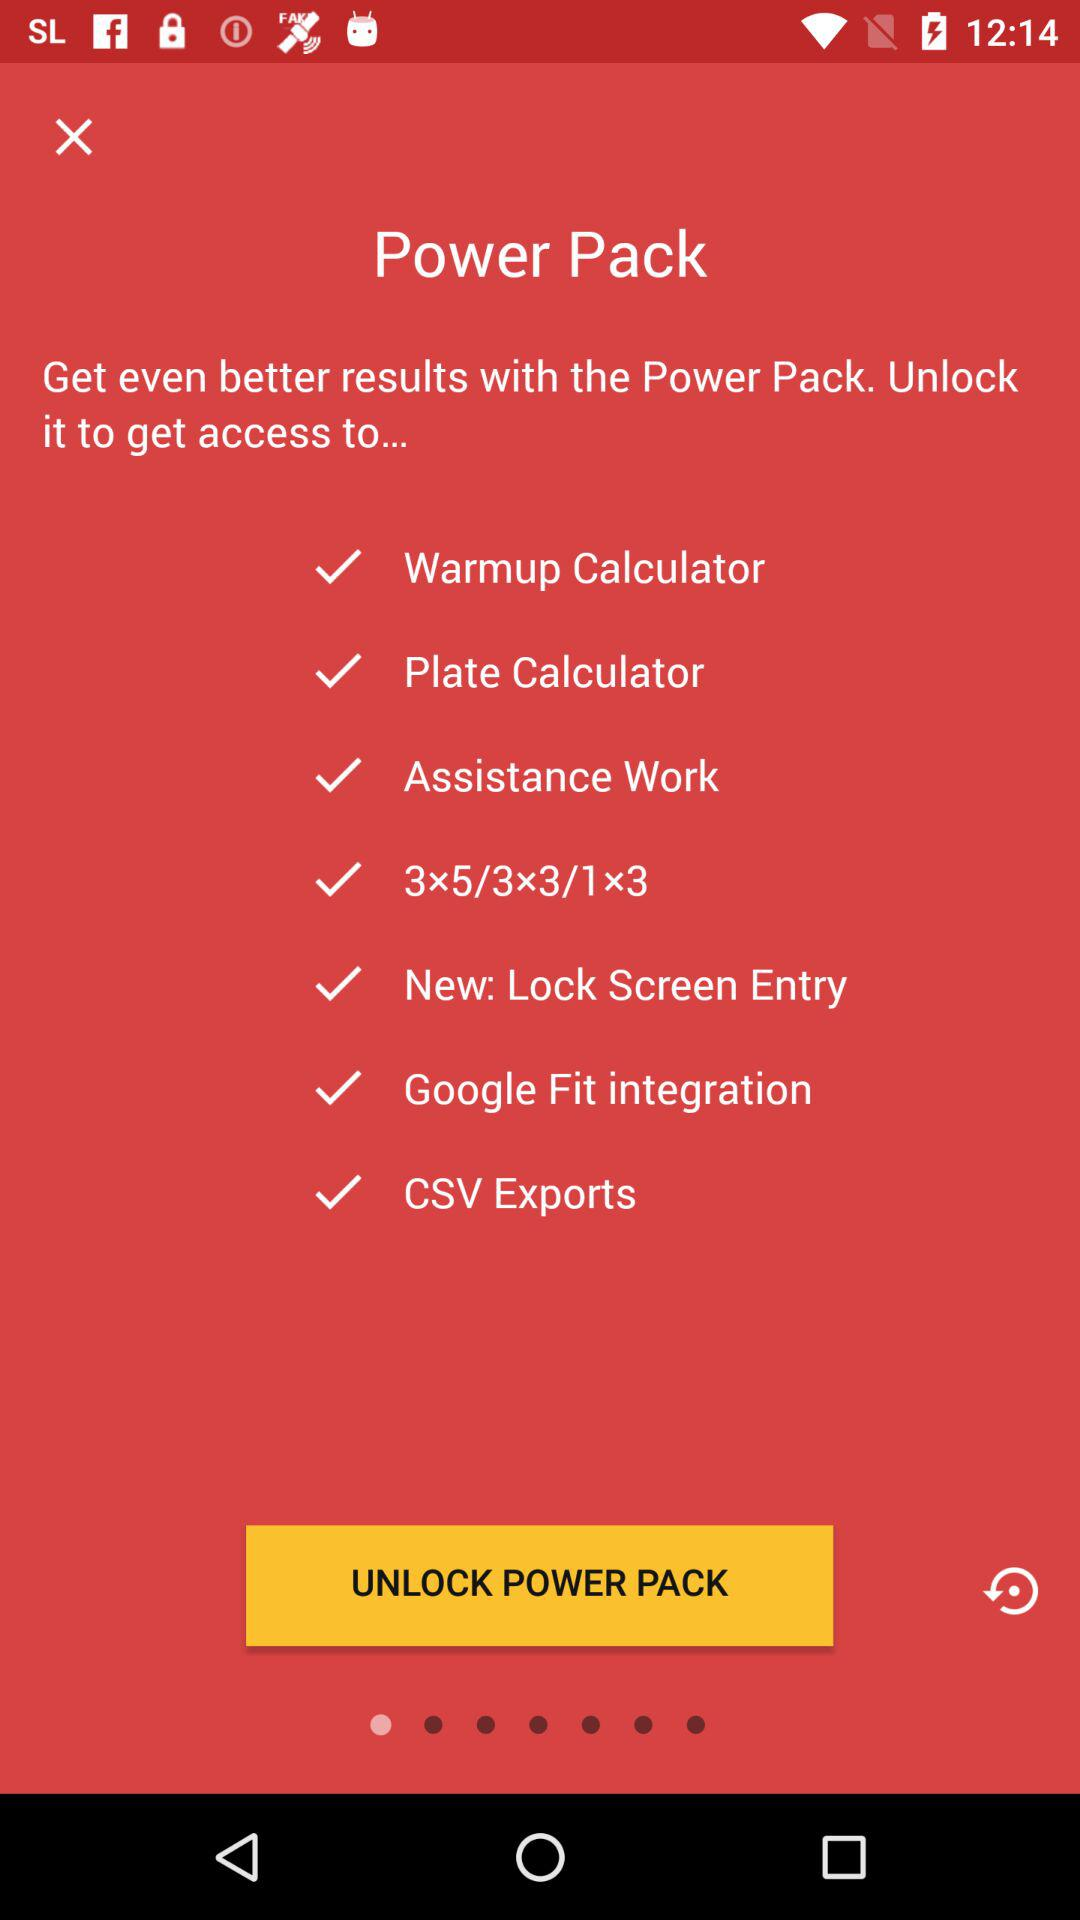What features will be accessible by unlocking the Power Pack? The features that will be accessible by unlocking the Power Pack are "Warmup Calculator", "Plate Calculator", "Assistance Work", "3×5/3×3/1x3", "New: Lock Screen Entry", "Google Fit integration" and "CSV Exports". 